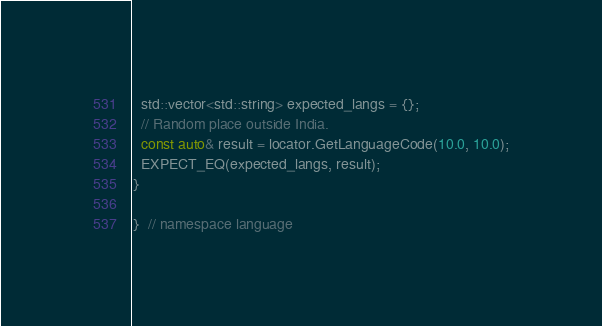Convert code to text. <code><loc_0><loc_0><loc_500><loc_500><_C++_>  std::vector<std::string> expected_langs = {};
  // Random place outside India.
  const auto& result = locator.GetLanguageCode(10.0, 10.0);
  EXPECT_EQ(expected_langs, result);
}

}  // namespace language
</code> 